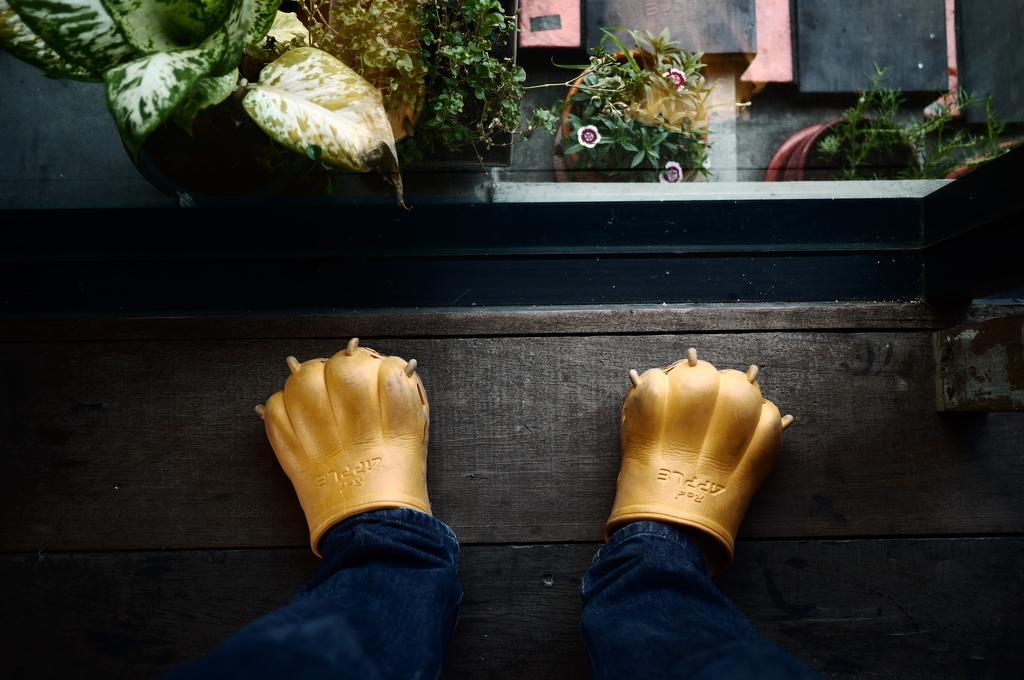Can you describe this image briefly? In this picture we can see a pair of jeans and gloves on the wooden path. Behind the gloves there are some pots with plants. 